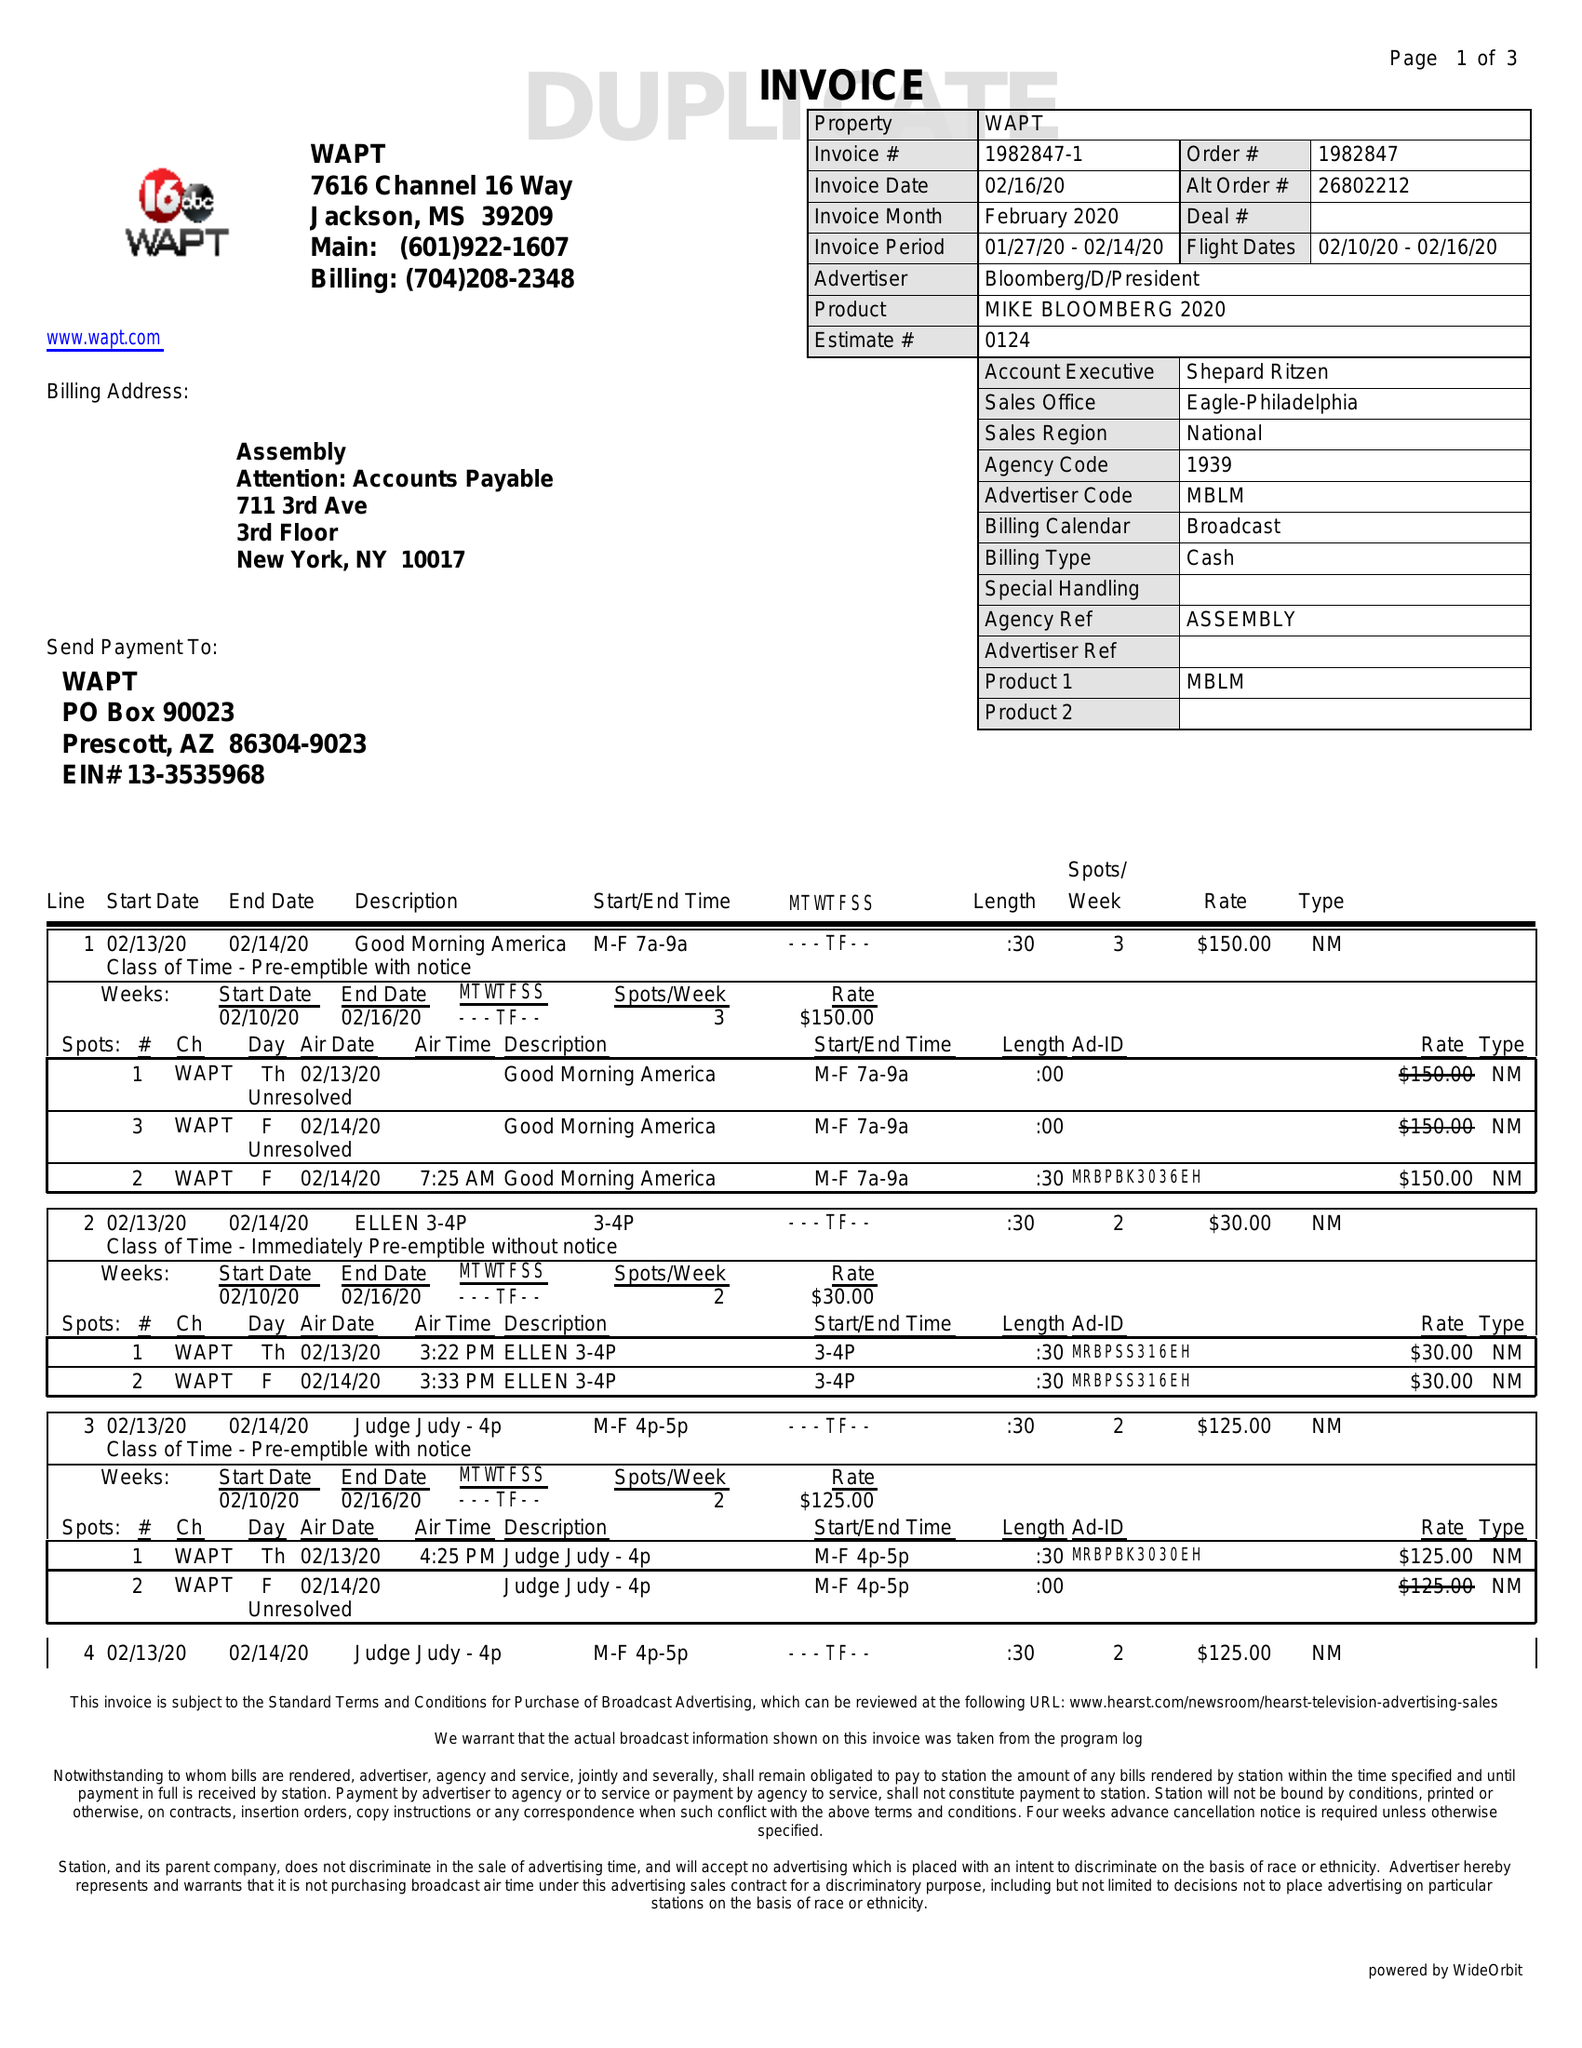What is the value for the flight_from?
Answer the question using a single word or phrase. 02/10/20 